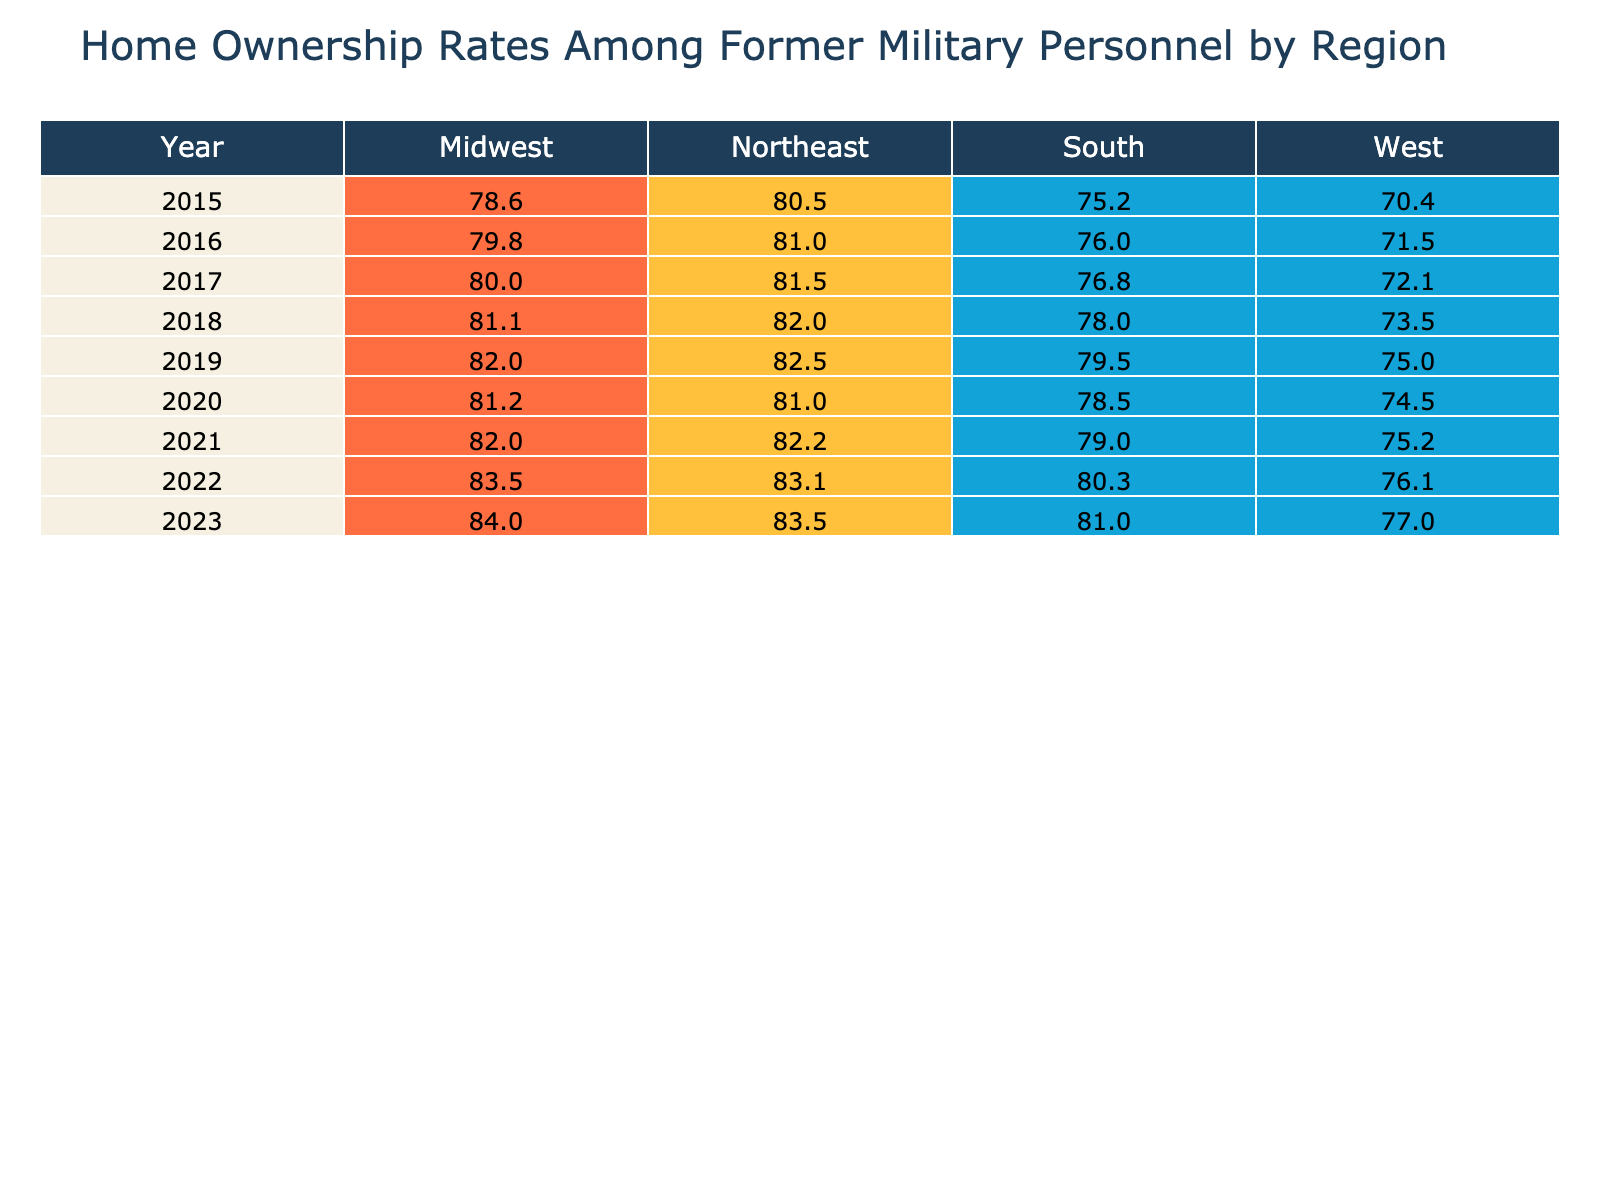What was the home ownership rate for former military personnel in 2020 in the South? In 2020, the South region has a home ownership rate of 78.5%, which is directly retrievable from the table under the corresponding year and region.
Answer: 78.5% Which region had the highest home ownership rate in 2023? By examining the home ownership rates for each region in 2023, we find that the Midwest had the highest rate at 84.0%, compared to 83.5% in the Northeast, 81.0% in the South, and 77.0% in the West.
Answer: Midwest What is the average home ownership rate from 2015 to 2022 for the West region? First, we gathered the home ownership rates for the West region over the years: 70.4%, 71.5%, 72.1%, 73.5%, 75.0%, 74.5%, 75.2%, 76.1%, and 77.0%. Their sum is 70.4 + 71.5 + 72.1 + 73.5 + 75.0 + 74.5 + 75.2 + 76.1 = 589.9. Dividing by the number of years (8) gives the average of 589.9 / 8 = 73.74.
Answer: 73.74 Did the home ownership rate among former military personnel in the Northeast increase from 2015 to 2023? Checking the rates, we see a rise from 80.5% in 2015 to 83.5% in 2023. Since the rate went up over this period, the answer is yes.
Answer: Yes What was the change in home ownership rate for the South region between 2015 and 2023? The home ownership rate in the South increased from 75.2% in 2015 to 81.0% in 2023. To find the change, we subtract the 2015 rate from the 2023 rate: 81.0 - 75.2 = 5.8%. This indicates an increase of 5.8 percentage points over the years.
Answer: 5.8% 